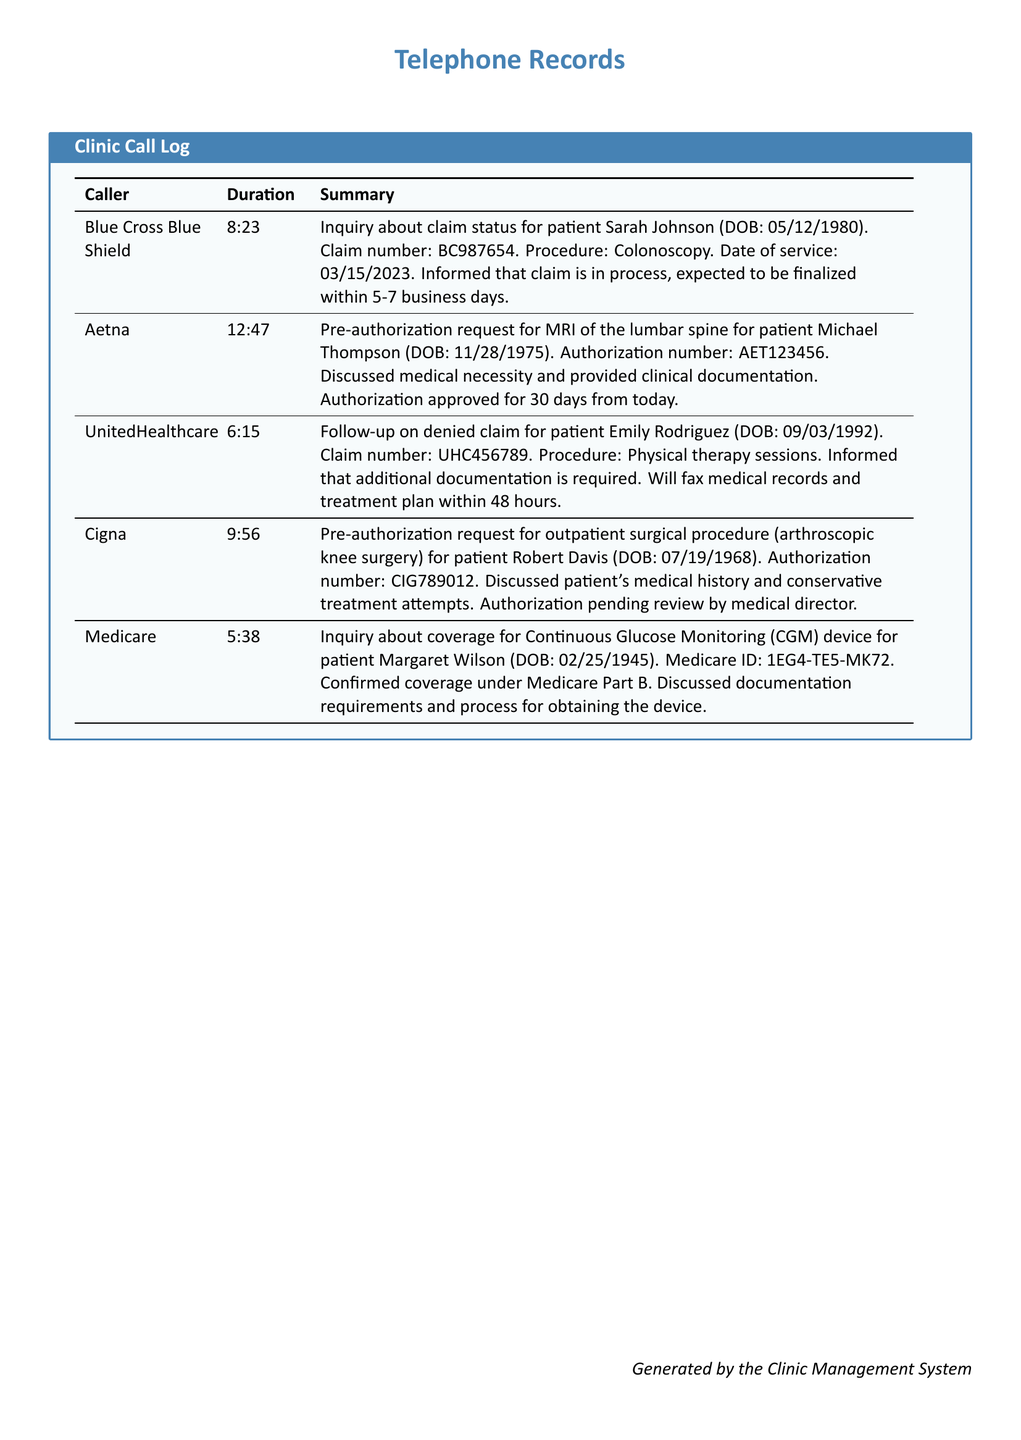What was the claim number for Sarah Johnson? The claim number for Sarah Johnson is provided in the document, which is BC987654.
Answer: BC987654 How long is the authorization approved for Michael Thompson? The document states that the authorization for Michael Thompson is approved for 30 days from today.
Answer: 30 days What procedure is being followed up by UnitedHealthcare for Emily Rodriguez? The document mentions that the procedure followed up by UnitedHealthcare for Emily Rodriguez is physical therapy sessions.
Answer: Physical therapy sessions What is the duration of the call with Cigna? The duration of the call with Cigna is listed in the document as 9:56.
Answer: 9:56 What is the Medicare ID for Margaret Wilson? The document provides the Medicare ID for Margaret Wilson, which is 1EG4-TE5-MK72.
Answer: 1EG4-TE5-MK72 What is the status of the authorization request for Robert Davis? The document indicates that the status of the authorization request for Robert Davis is pending review by the medical director.
Answer: Pending review by medical director How many business days until the claim for Sarah Johnson is finalized? The document specifies that the claim for Sarah Johnson is expected to be finalized within 5-7 business days.
Answer: 5-7 business days Which insurance company requested pre-authorization for an MRI? The document states that Aetna requested pre-authorization for an MRI of the lumbar spine.
Answer: Aetna Who discussed medical necessity and provided clinical documentation? The document notes that Aetna discussed medical necessity and provided clinical documentation for Michael Thompson's request.
Answer: Aetna 